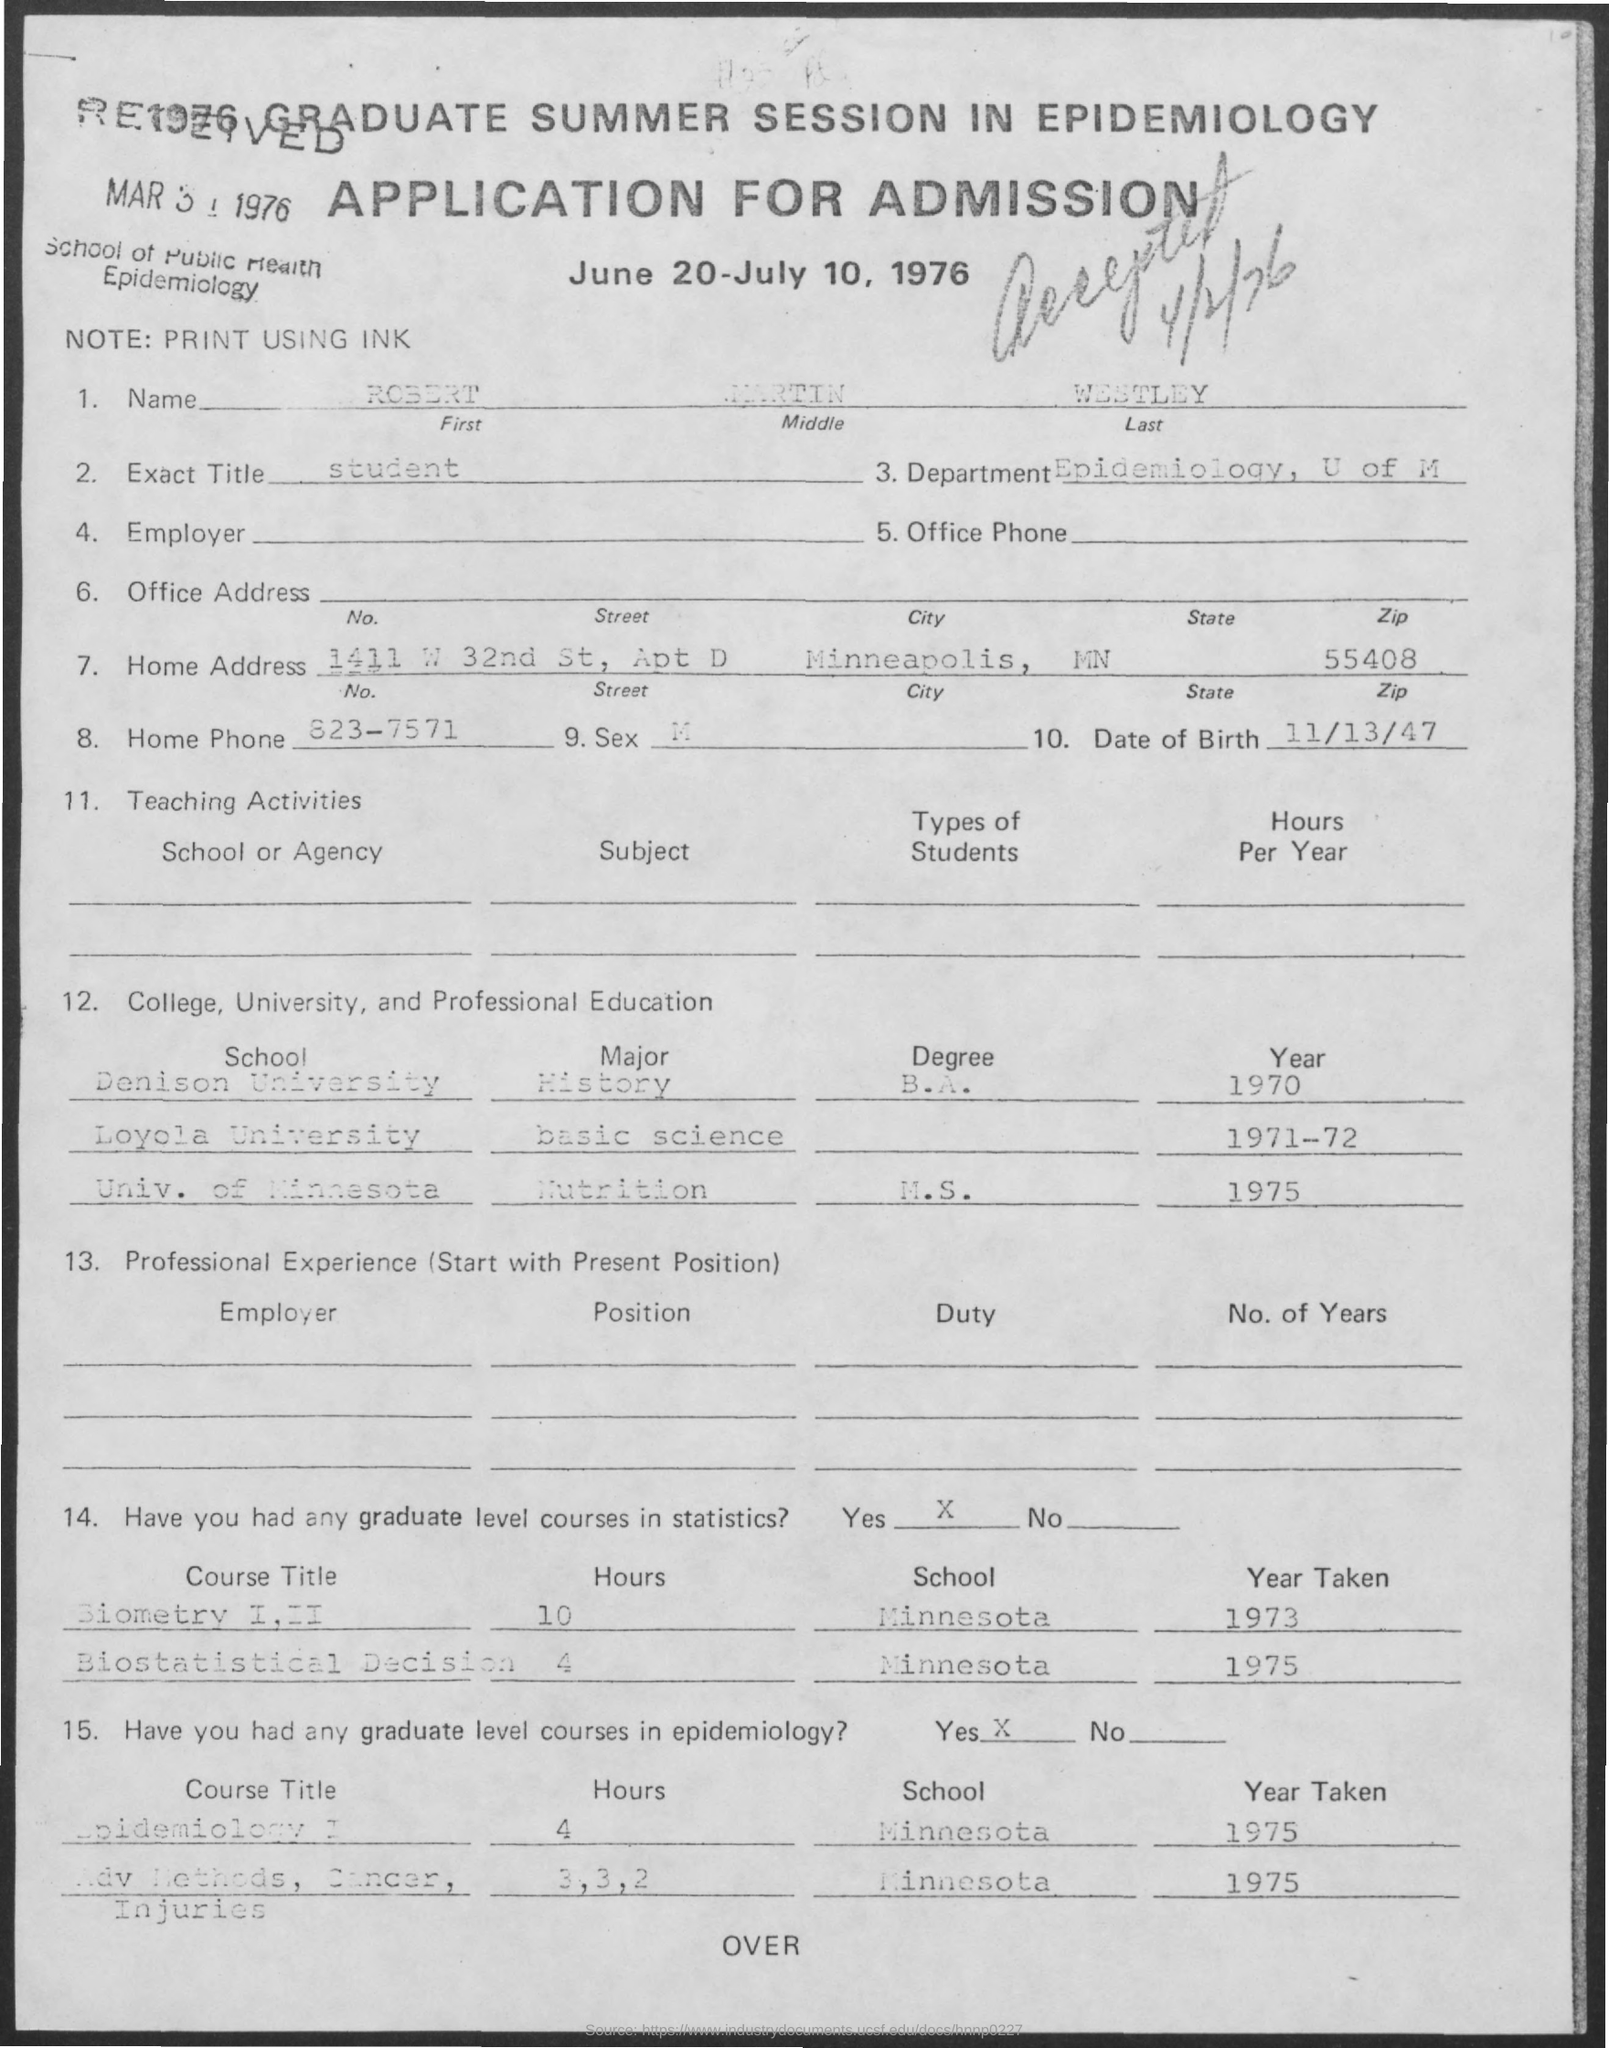what is the name mentioned ? The name mentioned in the document is 'Robert Martin Westley.' The document appears to be an application for admission to a Graduate Summer Session in Epidemiology dated between June 20-July 10, 1976. 